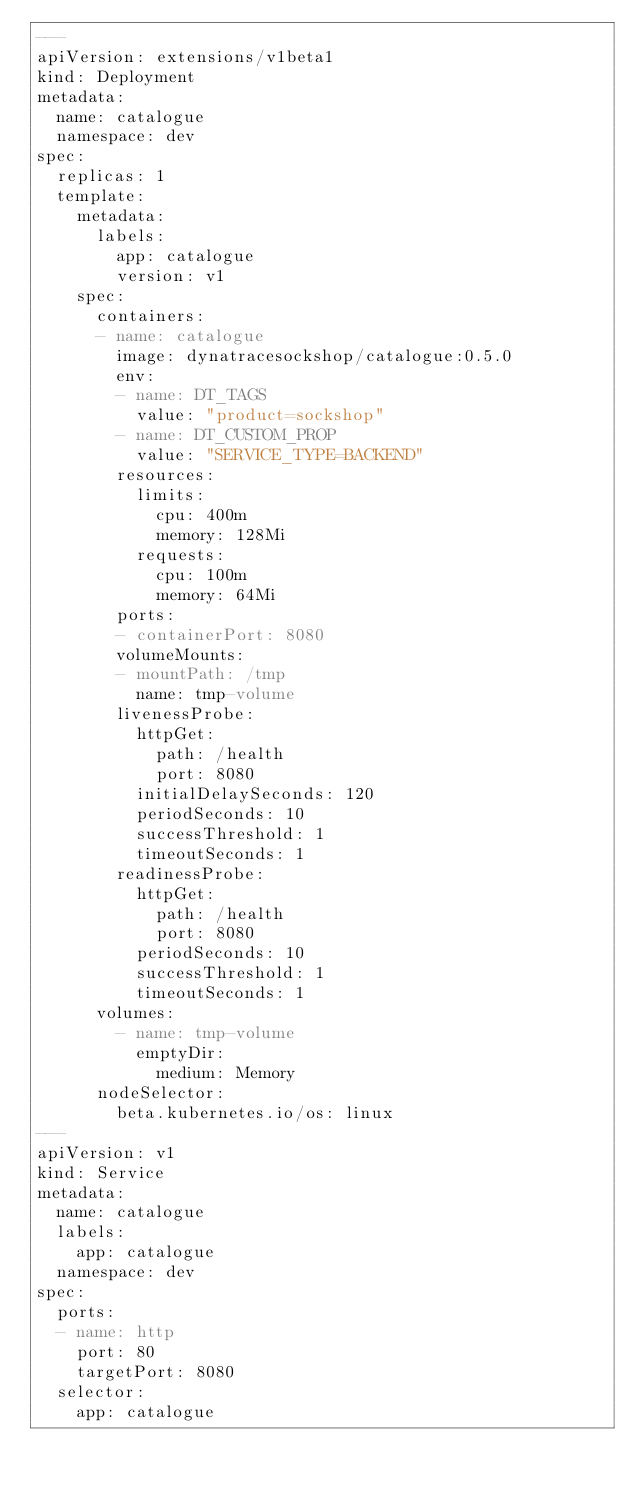Convert code to text. <code><loc_0><loc_0><loc_500><loc_500><_YAML_>---
apiVersion: extensions/v1beta1
kind: Deployment
metadata:
  name: catalogue
  namespace: dev
spec:
  replicas: 1
  template:
    metadata:
      labels:
        app: catalogue
        version: v1
    spec:
      containers:
      - name: catalogue
        image: dynatracesockshop/catalogue:0.5.0
        env: 
        - name: DT_TAGS
          value: "product=sockshop"
        - name: DT_CUSTOM_PROP
          value: "SERVICE_TYPE=BACKEND"
        resources:
          limits:
            cpu: 400m
            memory: 128Mi
          requests:
            cpu: 100m
            memory: 64Mi
        ports:
        - containerPort: 8080
        volumeMounts:
        - mountPath: /tmp
          name: tmp-volume
        livenessProbe:
          httpGet:
            path: /health
            port: 8080
          initialDelaySeconds: 120
          periodSeconds: 10
          successThreshold: 1
          timeoutSeconds: 1
        readinessProbe:
          httpGet:
            path: /health
            port: 8080
          periodSeconds: 10
          successThreshold: 1
          timeoutSeconds: 1
      volumes:
        - name: tmp-volume
          emptyDir:
            medium: Memory
      nodeSelector:
        beta.kubernetes.io/os: linux
---
apiVersion: v1
kind: Service
metadata:
  name: catalogue
  labels:
    app: catalogue
  namespace: dev
spec:
  ports:
  - name: http
    port: 80
    targetPort: 8080
  selector:
    app: catalogue
</code> 